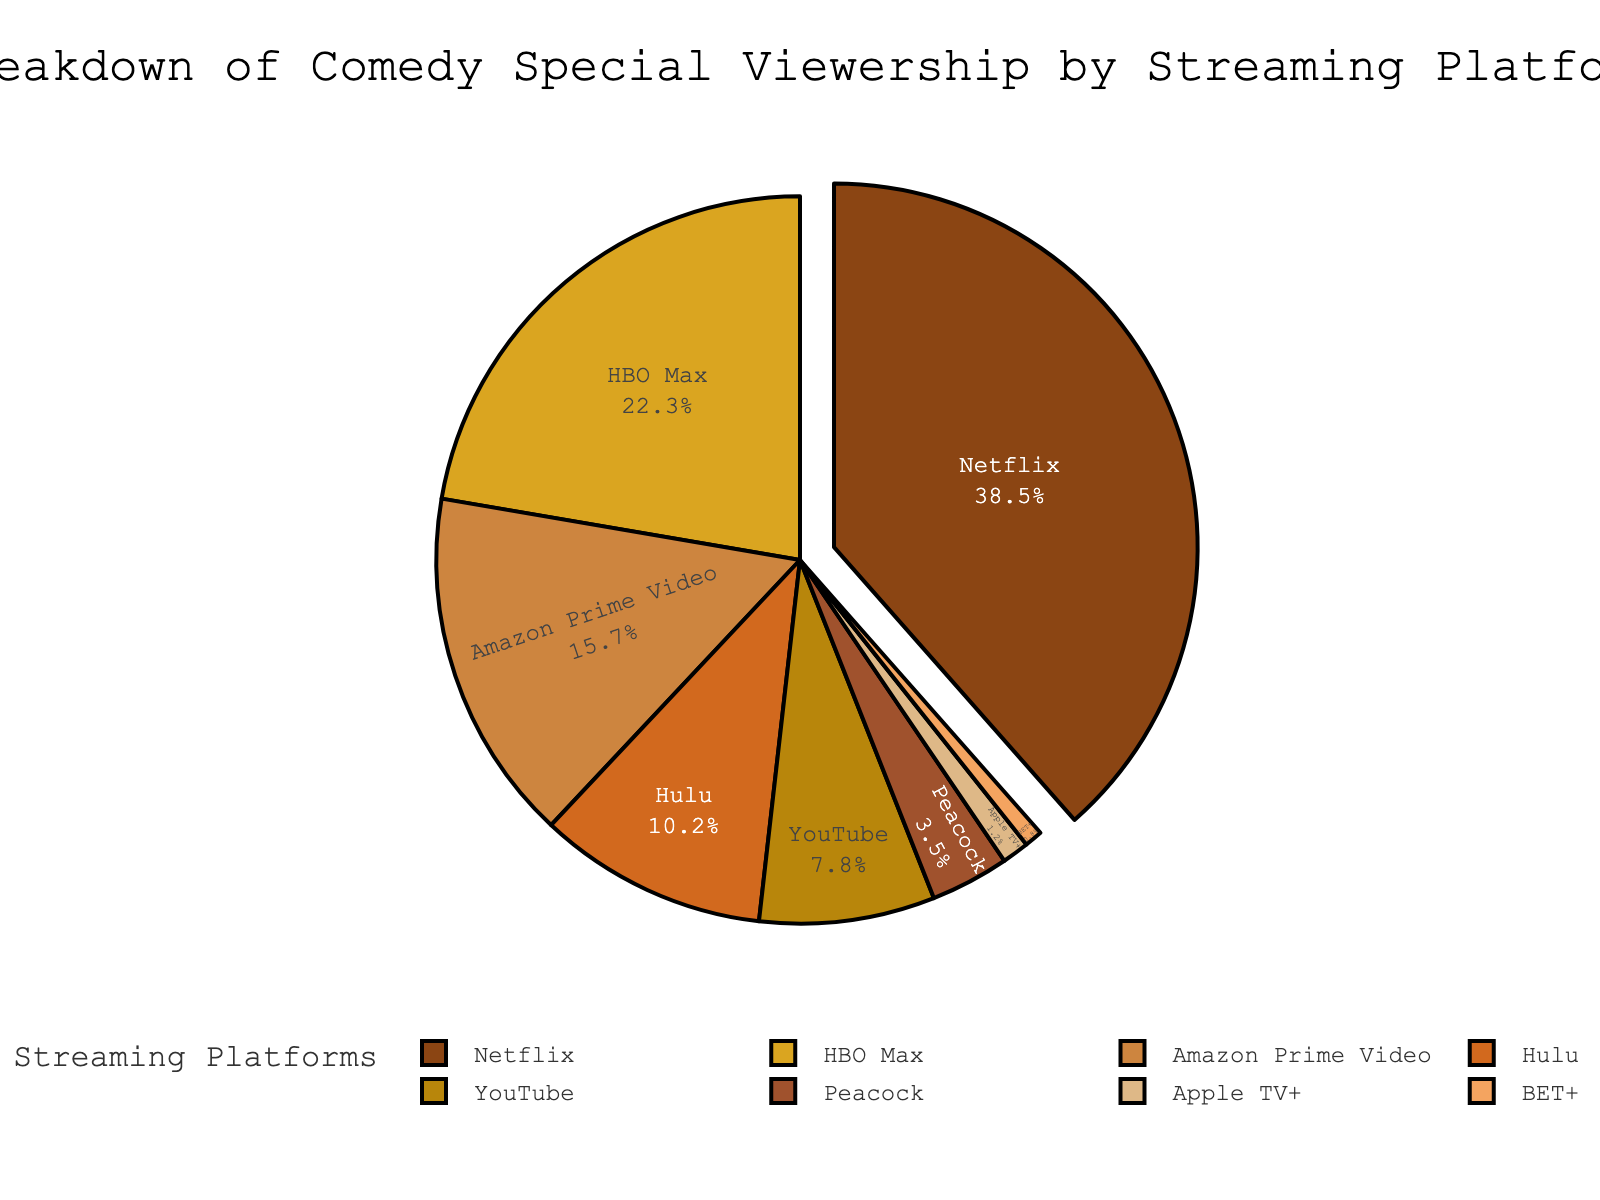Which streaming platform has the highest viewership percentage? The figure shows that Netflix has the largest segment of the pie chart.
Answer: Netflix What's the combined viewership percentage of HBO Max and Amazon Prime Video? Add the percentages for HBO Max (22.3%) and Amazon Prime Video (15.7%): 22.3 + 15.7 = 38.0%.
Answer: 38.0% Which platforms have a viewership percentage greater than 10%? The platforms with segments larger than 10% in the pie chart are Netflix, HBO Max, Amazon Prime Video, and Hulu.
Answer: Netflix, HBO Max, Amazon Prime Video, Hulu By how much does Netflix's viewership percentage exceed Hulu's? Subtract Hulu's percentage (10.2%) from Netflix's percentage (38.5%): 38.5 - 10.2 = 28.3%.
Answer: 28.3% What is the percentage difference between Peacock and Apple TV+? Subtract Apple TV+'s percentage (1.2%) from Peacock's percentage (3.5%): 3.5 - 1.2 = 2.3%.
Answer: 2.3% Which platform has the smallest viewership percentage? The smallest segment of the pie chart belongs to BET+ with 0.8%.
Answer: BET+ Name the platforms with viewership between 15% and 25%. The platforms falling within this range are HBO Max (22.3%) and Amazon Prime Video (15.7%).
Answer: HBO Max, Amazon Prime Video Calculate the total viewership percentage of YouTube, Peacock, and Apple TV+. Add the percentages for YouTube (7.8%), Peacock (3.5%), and Apple TV+ (1.2%): 7.8 + 3.5 + 1.2 = 12.5%.
Answer: 12.5% How many platforms have a viewership percentage less than 5%? The platforms with less than 5% are Peacock (3.5%), Apple TV+ (1.2%), and BET+ (0.8%). This means there are 3 platforms.
Answer: 3 Which platform follows Hulu in terms of viewership percentage? Hulu has a viewership percentage of 10.2%, and the next largest segment belongs to YouTube with 7.8%.
Answer: YouTube 